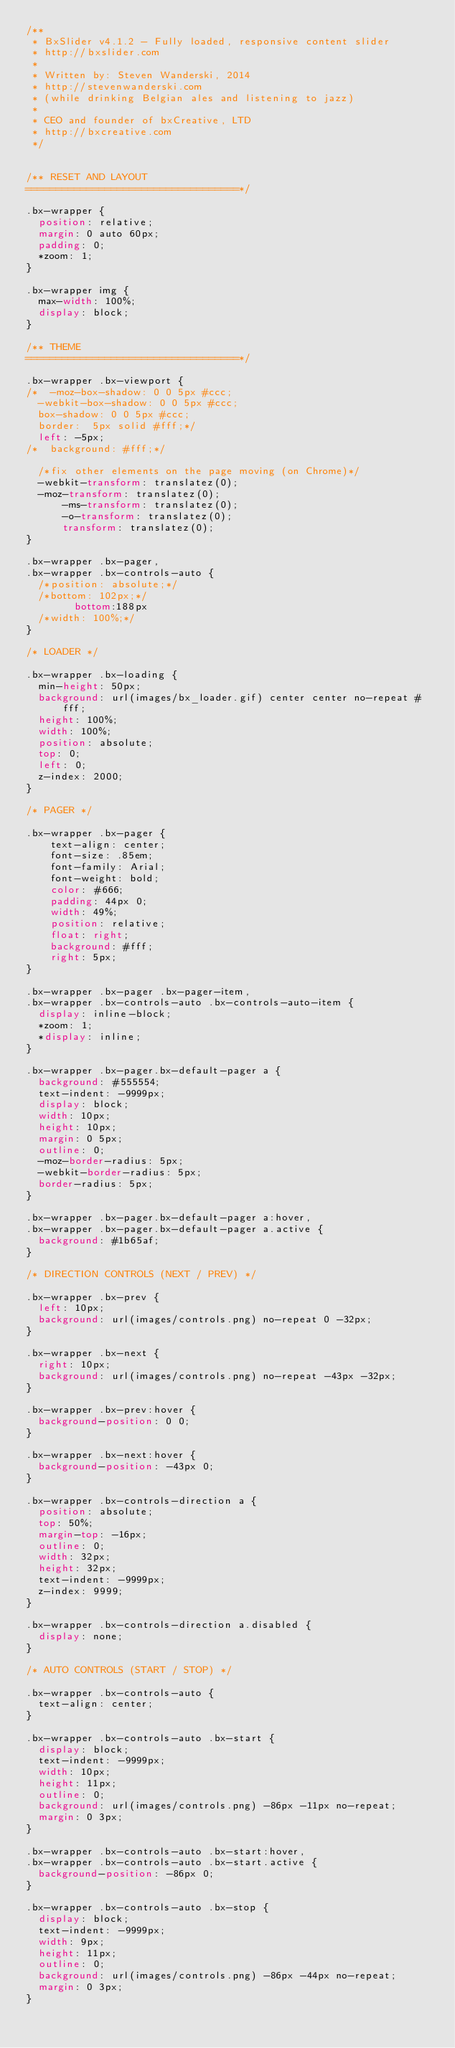Convert code to text. <code><loc_0><loc_0><loc_500><loc_500><_CSS_>/**
 * BxSlider v4.1.2 - Fully loaded, responsive content slider
 * http://bxslider.com
 *
 * Written by: Steven Wanderski, 2014
 * http://stevenwanderski.com
 * (while drinking Belgian ales and listening to jazz)
 *
 * CEO and founder of bxCreative, LTD
 * http://bxcreative.com
 */


/** RESET AND LAYOUT
===================================*/

.bx-wrapper {
	position: relative;
	margin: 0 auto 60px;
	padding: 0;
	*zoom: 1;
}

.bx-wrapper img {
	max-width: 100%;
	display: block;
}

/** THEME
===================================*/

.bx-wrapper .bx-viewport {
/*	-moz-box-shadow: 0 0 5px #ccc;
	-webkit-box-shadow: 0 0 5px #ccc;
	box-shadow: 0 0 5px #ccc;
	border:  5px solid #fff;*/
	left: -5px;
/*	background: #fff;*/
	
	/*fix other elements on the page moving (on Chrome)*/
	-webkit-transform: translatez(0);
	-moz-transform: translatez(0);
    	-ms-transform: translatez(0);
    	-o-transform: translatez(0);
    	transform: translatez(0);
}

.bx-wrapper .bx-pager,
.bx-wrapper .bx-controls-auto {
	/*position: absolute;*/
	/*bottom: 102px;*/
        bottom:188px
	/*width: 100%;*/
}

/* LOADER */

.bx-wrapper .bx-loading {
	min-height: 50px;
	background: url(images/bx_loader.gif) center center no-repeat #fff;
	height: 100%;
	width: 100%;
	position: absolute;
	top: 0;
	left: 0;
	z-index: 2000;
}

/* PAGER */

.bx-wrapper .bx-pager {
    text-align: center;
    font-size: .85em;
    font-family: Arial;
    font-weight: bold;
    color: #666;
    padding: 44px 0;
    width: 49%;
    position: relative;
    float: right;
    background: #fff;
    right: 5px;
}

.bx-wrapper .bx-pager .bx-pager-item,
.bx-wrapper .bx-controls-auto .bx-controls-auto-item {
	display: inline-block;
	*zoom: 1;
	*display: inline;
}

.bx-wrapper .bx-pager.bx-default-pager a {
	background: #555554;
	text-indent: -9999px;
	display: block;
	width: 10px;
	height: 10px;
	margin: 0 5px;
	outline: 0;
	-moz-border-radius: 5px;
	-webkit-border-radius: 5px;
	border-radius: 5px;
}

.bx-wrapper .bx-pager.bx-default-pager a:hover,
.bx-wrapper .bx-pager.bx-default-pager a.active {
	background: #1b65af;
}

/* DIRECTION CONTROLS (NEXT / PREV) */

.bx-wrapper .bx-prev {
	left: 10px;
	background: url(images/controls.png) no-repeat 0 -32px;
}

.bx-wrapper .bx-next {
	right: 10px;
	background: url(images/controls.png) no-repeat -43px -32px;
}

.bx-wrapper .bx-prev:hover {
	background-position: 0 0;
}

.bx-wrapper .bx-next:hover {
	background-position: -43px 0;
}

.bx-wrapper .bx-controls-direction a {
	position: absolute;
	top: 50%;
	margin-top: -16px;
	outline: 0;
	width: 32px;
	height: 32px;
	text-indent: -9999px;
	z-index: 9999;
}

.bx-wrapper .bx-controls-direction a.disabled {
	display: none;
}

/* AUTO CONTROLS (START / STOP) */

.bx-wrapper .bx-controls-auto {
	text-align: center;
}

.bx-wrapper .bx-controls-auto .bx-start {
	display: block;
	text-indent: -9999px;
	width: 10px;
	height: 11px;
	outline: 0;
	background: url(images/controls.png) -86px -11px no-repeat;
	margin: 0 3px;
}

.bx-wrapper .bx-controls-auto .bx-start:hover,
.bx-wrapper .bx-controls-auto .bx-start.active {
	background-position: -86px 0;
}

.bx-wrapper .bx-controls-auto .bx-stop {
	display: block;
	text-indent: -9999px;
	width: 9px;
	height: 11px;
	outline: 0;
	background: url(images/controls.png) -86px -44px no-repeat;
	margin: 0 3px;
}
</code> 